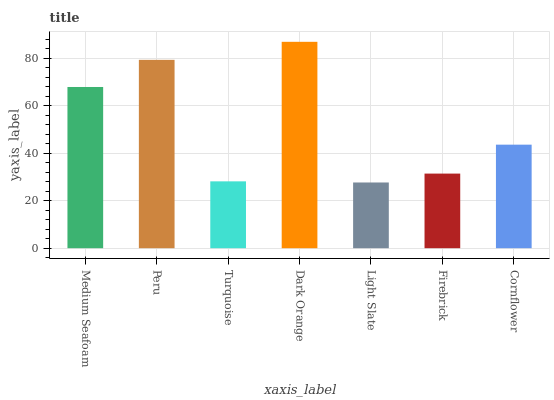Is Light Slate the minimum?
Answer yes or no. Yes. Is Dark Orange the maximum?
Answer yes or no. Yes. Is Peru the minimum?
Answer yes or no. No. Is Peru the maximum?
Answer yes or no. No. Is Peru greater than Medium Seafoam?
Answer yes or no. Yes. Is Medium Seafoam less than Peru?
Answer yes or no. Yes. Is Medium Seafoam greater than Peru?
Answer yes or no. No. Is Peru less than Medium Seafoam?
Answer yes or no. No. Is Cornflower the high median?
Answer yes or no. Yes. Is Cornflower the low median?
Answer yes or no. Yes. Is Firebrick the high median?
Answer yes or no. No. Is Medium Seafoam the low median?
Answer yes or no. No. 